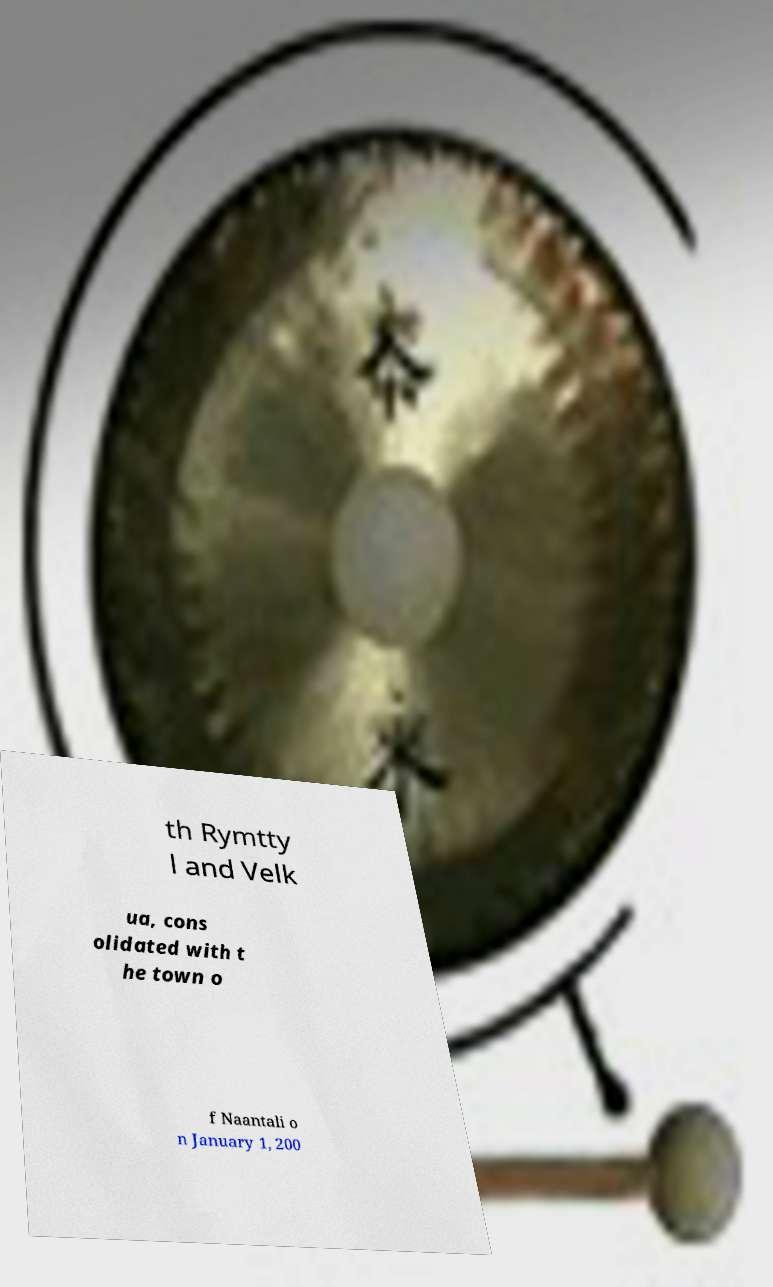I need the written content from this picture converted into text. Can you do that? th Rymtty l and Velk ua, cons olidated with t he town o f Naantali o n January 1, 200 